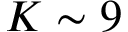Convert formula to latex. <formula><loc_0><loc_0><loc_500><loc_500>K \sim 9</formula> 